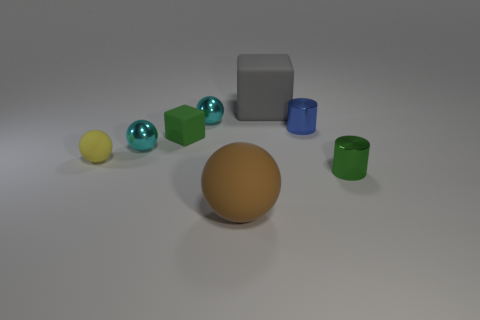Add 2 yellow things. How many objects exist? 10 Subtract all cubes. How many objects are left? 6 Add 3 metal spheres. How many metal spheres exist? 5 Subtract 1 yellow balls. How many objects are left? 7 Subtract all big gray shiny objects. Subtract all tiny matte cubes. How many objects are left? 7 Add 6 cyan objects. How many cyan objects are left? 8 